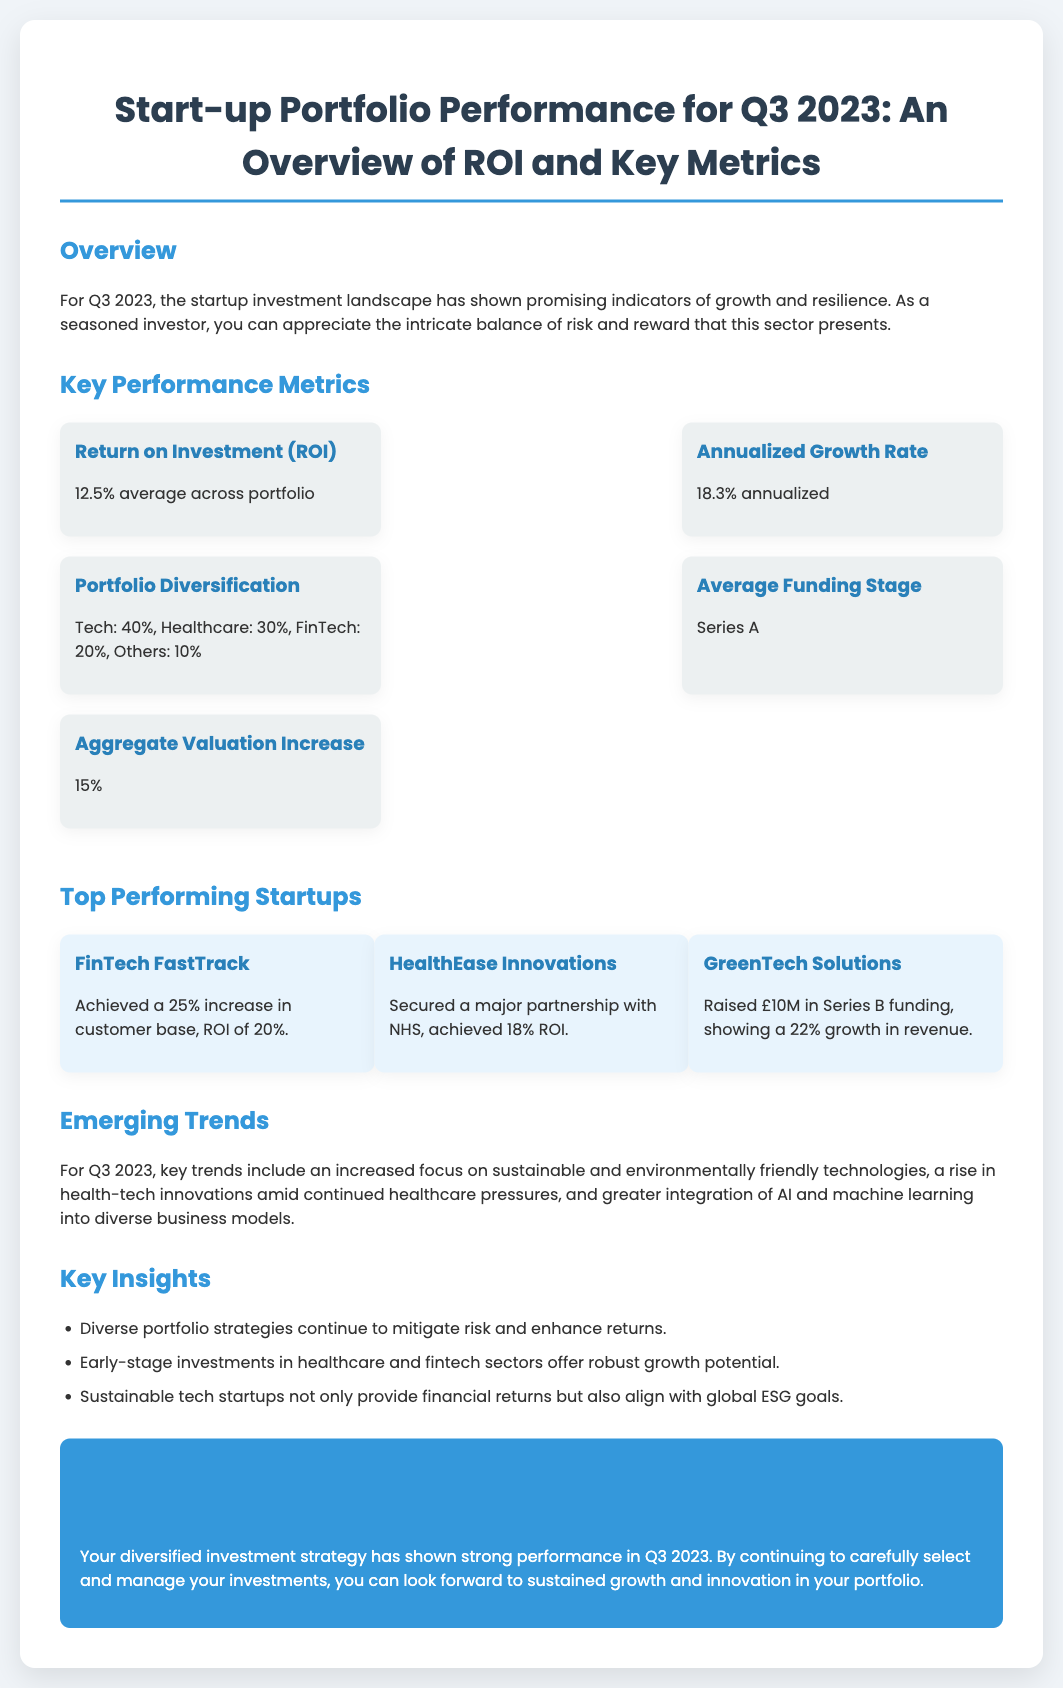what is the average Return on Investment (ROI)? The average ROI is provided as a metric in the document.
Answer: 12.5% what is the percentage of the portfolio allocated to Healthcare? The document details the portfolio diversification metrics, specifically the percentage allocated to Healthcare.
Answer: 30% which startup achieved a 25% increase in customer base? This information is detailed in the section highlighting the top-performing startups.
Answer: FinTech FastTrack what is the aggregate valuation increase reported? The document states the aggregate valuation increase as a key performance metric.
Answer: 15% what is the annualized growth rate? The annualized growth rate is highlighted as one of the key performance metrics in the document.
Answer: 18.3% which sector shows the highest allocation in the portfolio? The document provides insights into the distribution of the portfolio across different sectors.
Answer: Tech what trend is emphasized for Q3 2023? The document outlines a significant trend observed in Q3 2023 within the startup landscape.
Answer: Sustainable technologies how many startups are listed in the top-performing section? The document lists startups under the top-performing section, indicating the count of those startups.
Answer: 3 what relationship does the document suggest between sustainable tech startups and global goals? Findings in the document discuss the broader impact of sustainable tech startups.
Answer: Align with global ESG goals what is the average funding stage mentioned in the document? The average funding stage for the startups in the portfolio is presented as a key performance metric.
Answer: Series A 